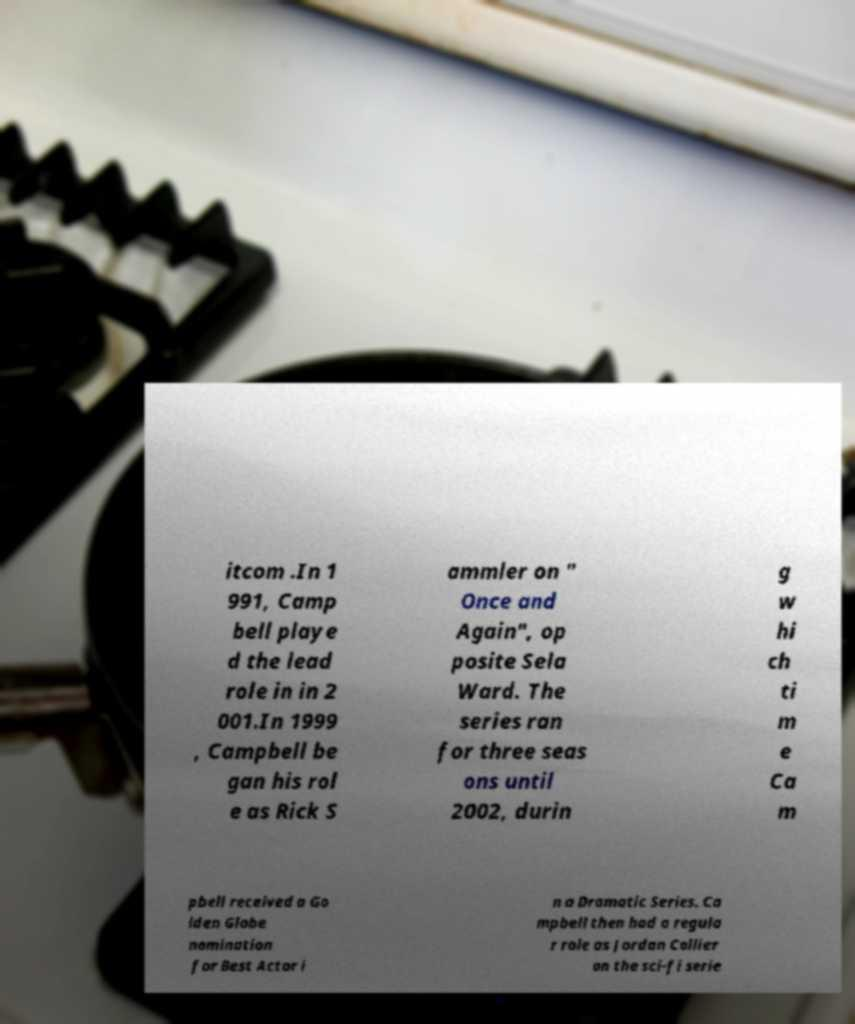Please read and relay the text visible in this image. What does it say? itcom .In 1 991, Camp bell playe d the lead role in in 2 001.In 1999 , Campbell be gan his rol e as Rick S ammler on " Once and Again", op posite Sela Ward. The series ran for three seas ons until 2002, durin g w hi ch ti m e Ca m pbell received a Go lden Globe nomination for Best Actor i n a Dramatic Series. Ca mpbell then had a regula r role as Jordan Collier on the sci-fi serie 